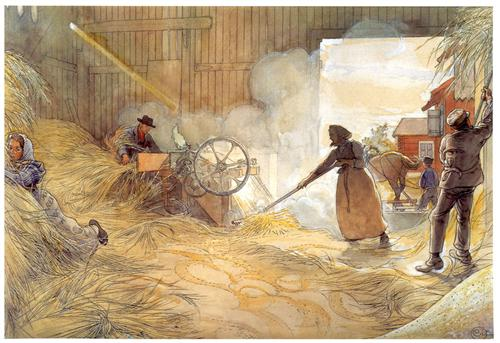Can you describe the tools being used in the painting? In the painting, various traditional agricultural tools can be observed. A prominent feature is a large threshing machine, positioned centrally, operated by one of the workers. This machine is essential for separating the grain from the stalks. Additionally, a pitchfork can be seen held by one of the workers on the right-hand side, used for moving the straw. The woman uses a hand-held flail to beat the grain, a common practice in manual threshing. These tools collectively highlight the manual and labor-intensive nature of grain threshing during that era. What might be the daily routine of the people depicted in this painting? The daily routine of the individuals in the painting likely revolves around agricultural tasks that begin early in the morning. Their day might start with tending to animals and preparing the barn for threshing. They would gather in the barn, where each person has a specific role, operating machinery, moving straw, or manually threshing grain. By mid-day, they might pause for a communal meal, taking a moment to rest and socialize. In the afternoon, they would continue their work, ensuring that all the grain is processed before evening. This routine reflects the cooperative and communal nature of rural farming communities. If this painting could tell a story, what would it be? If this painting could tell a story, it would narrate a day in the life of a tight-knit farming community. The story would unfold from the break of dawn with the first light streaming into the barn, as men and women come together for the collective task of threshing grain. It would speak of the rhythmic sounds of labor, the hum of the threshing machine, the swoosh of the flail, and the soft murmur of conversations as they work. Amidst the toil, there would be moments of shared laughter, encouragement, and camaraderie, highlighting the bonds that hold the community together. The painting would end with the sun setting, casting a golden hue over the barn, as the workers, tired but content, share a meal and reflect on their day's work. This story is a tribute to the resilience, hard work, and unity of people who find joy and purpose in their shared labor. 